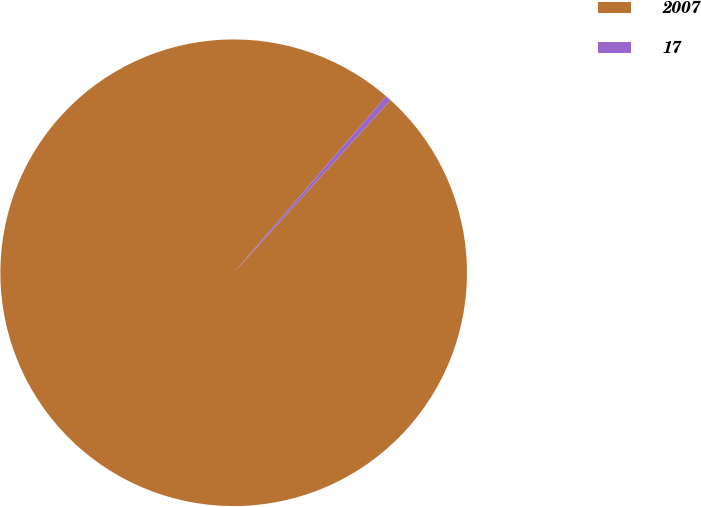Convert chart. <chart><loc_0><loc_0><loc_500><loc_500><pie_chart><fcel>2007<fcel>17<nl><fcel>99.6%<fcel>0.4%<nl></chart> 